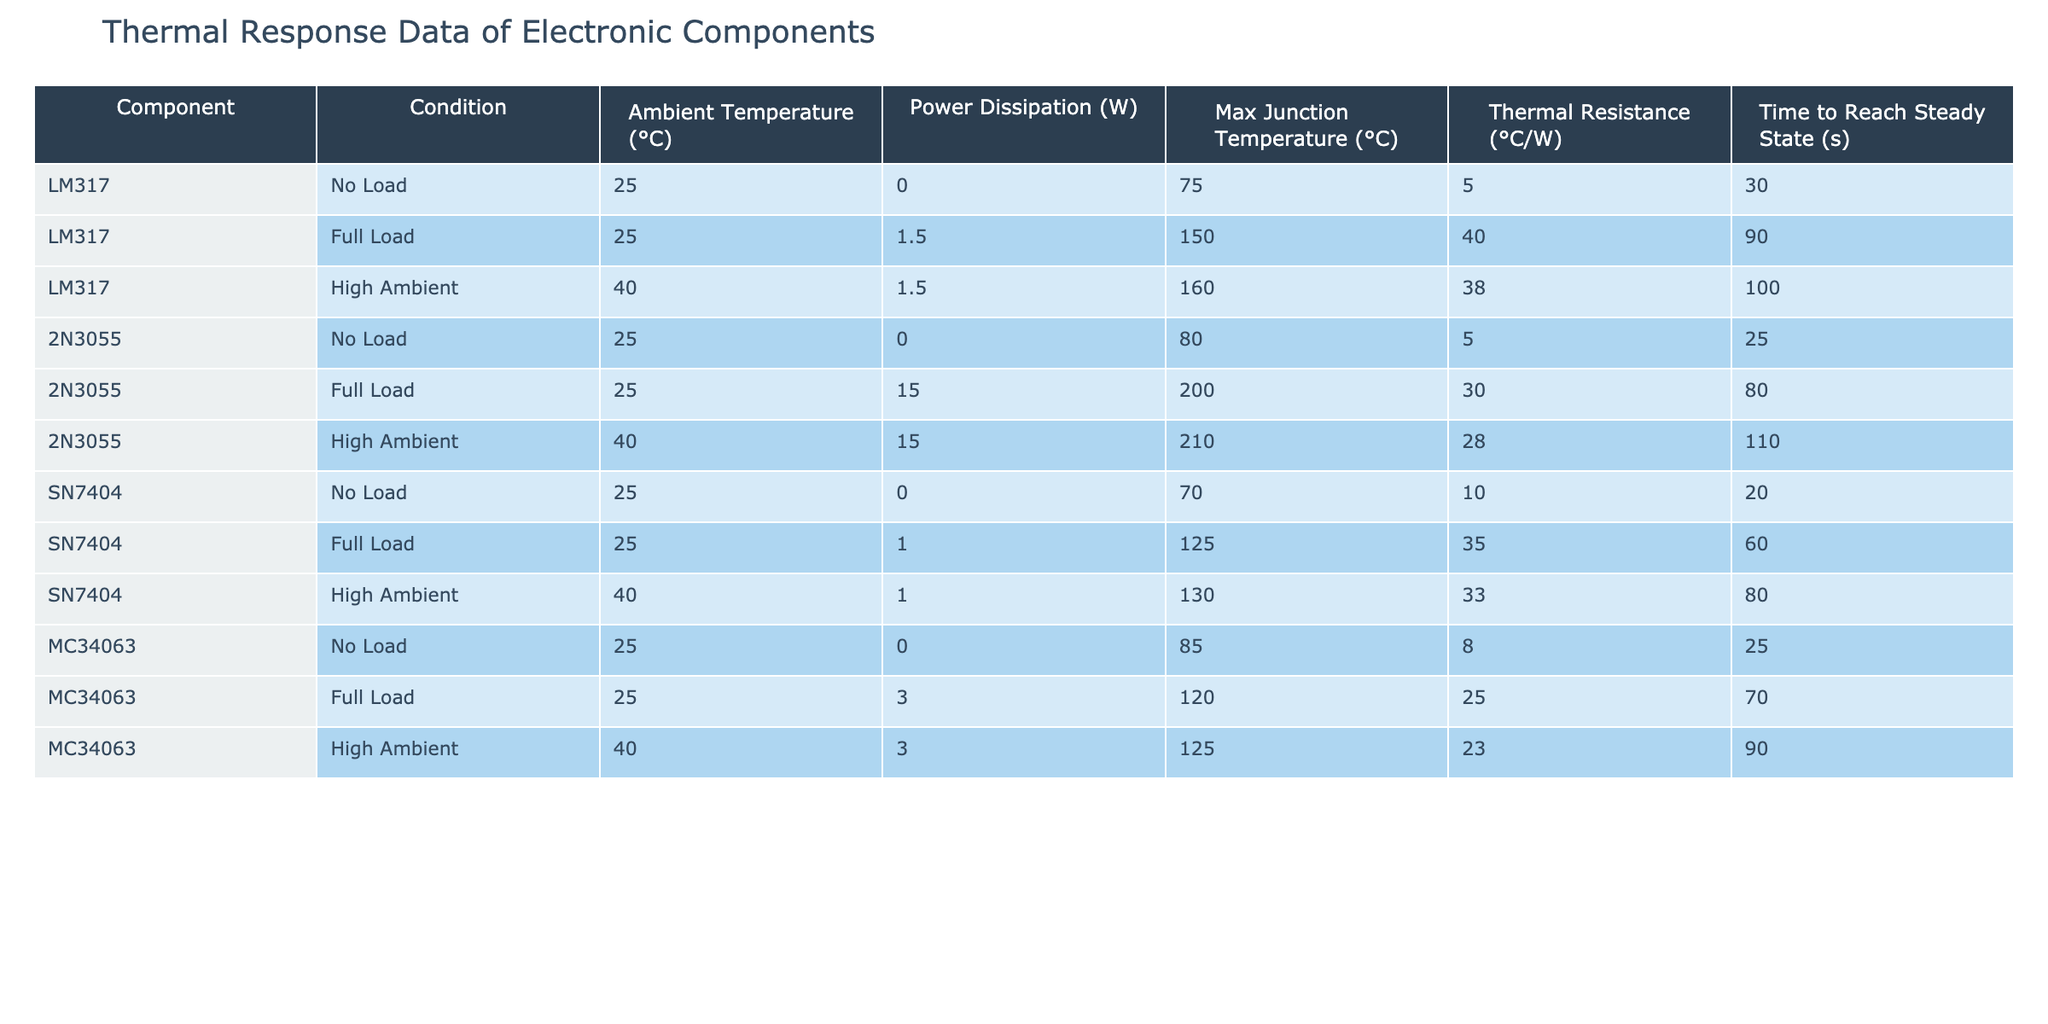What is the maximum junction temperature for the 2N3055 under full load? Under the "2N3055, Full Load" condition, the maximum junction temperature listed in the table is 200 °C.
Answer: 200 °C What is the thermal resistance value of the LM317 under high ambient conditions? Referring to the "LM317, High Ambient" row, the thermal resistance is noted as 38 °C/W.
Answer: 38 °C/W Is the time to reach steady state shorter for the MC34063 under no load or full load conditions? The time to reach steady state for MC34063 is 25 seconds under no load and 70 seconds under full load. Thus, the no-load condition has a shorter time.
Answer: No load What is the average maximum junction temperature for all components under full load conditions? The maximum junction temperatures for full load are 150 °C (LM317), 200 °C (2N3055), 125 °C (SN7404), and 120 °C (MC34063). Adding these gives 595 °C total for 4 components, which results in an average of 595/4 = 148.75 °C.
Answer: 148.75 °C Does the SN7404 have a higher thermal resistance under full load or high ambient conditions? The thermal resistance for SN7404 under full load is 35 °C/W, and under high ambient conditions, it is 33 °C/W. Since 35 is greater than 33, the thermal resistance is higher under full load conditions.
Answer: Yes What is the difference in maximum junction temperature between the 2N3055 under full load and the high ambient condition? The maximum junction temperature for 2N3055 under full load is 200 °C, and under high ambient is 210 °C. The difference is 210 - 200 = 10 °C.
Answer: 10 °C Which component has the highest power dissipation under no load conditions? All components listed have zero power dissipation under no load conditions, meaning they all share the same value of 0 W.
Answer: 0 W What is the thermal resistance of the MC34063 under full load conditions? The thermal resistance for MC34063 under full load is presented in the table as 25 °C/W.
Answer: 25 °C/W Is it true that LM317 has a longer time to reach steady state under full load than under high ambient conditions? The time to reach steady state for LM317 under full load is 90 seconds, while under high ambient conditions, it is 100 seconds. Therefore, it is true that it takes longer under full load.
Answer: Yes 